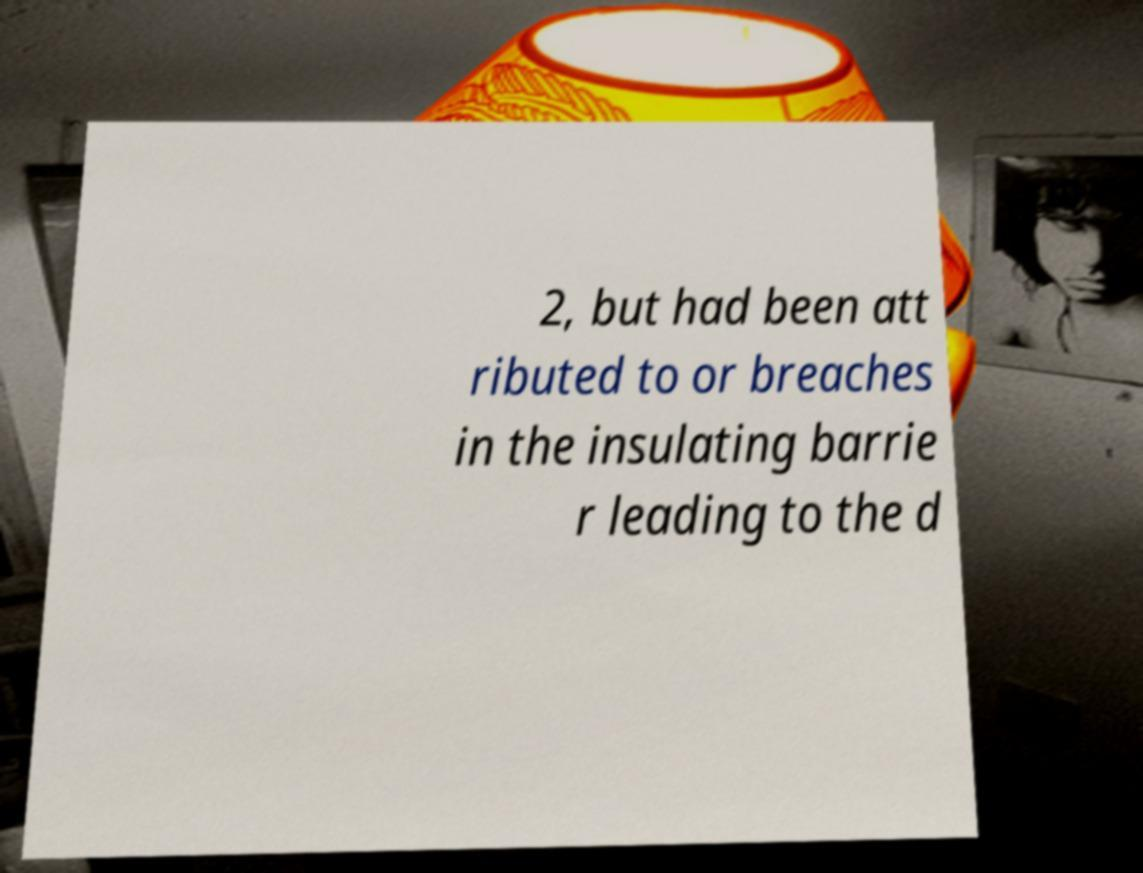Can you read and provide the text displayed in the image?This photo seems to have some interesting text. Can you extract and type it out for me? 2, but had been att ributed to or breaches in the insulating barrie r leading to the d 